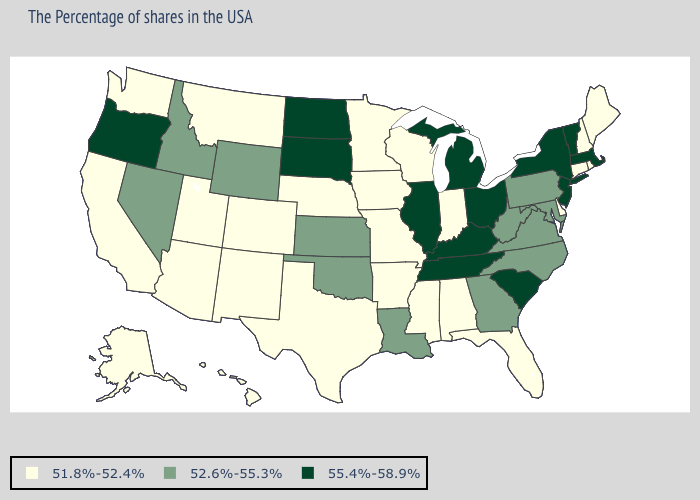How many symbols are there in the legend?
Concise answer only. 3. Does Florida have a lower value than Missouri?
Concise answer only. No. Which states hav the highest value in the West?
Give a very brief answer. Oregon. What is the value of Maryland?
Short answer required. 52.6%-55.3%. Does Ohio have the highest value in the USA?
Quick response, please. Yes. What is the lowest value in states that border Wisconsin?
Concise answer only. 51.8%-52.4%. Name the states that have a value in the range 52.6%-55.3%?
Be succinct. Maryland, Pennsylvania, Virginia, North Carolina, West Virginia, Georgia, Louisiana, Kansas, Oklahoma, Wyoming, Idaho, Nevada. Name the states that have a value in the range 52.6%-55.3%?
Quick response, please. Maryland, Pennsylvania, Virginia, North Carolina, West Virginia, Georgia, Louisiana, Kansas, Oklahoma, Wyoming, Idaho, Nevada. What is the lowest value in states that border Kansas?
Write a very short answer. 51.8%-52.4%. Which states have the lowest value in the Northeast?
Concise answer only. Maine, Rhode Island, New Hampshire, Connecticut. Does South Carolina have the lowest value in the South?
Be succinct. No. What is the highest value in the Northeast ?
Be succinct. 55.4%-58.9%. Which states have the highest value in the USA?
Short answer required. Massachusetts, Vermont, New York, New Jersey, South Carolina, Ohio, Michigan, Kentucky, Tennessee, Illinois, South Dakota, North Dakota, Oregon. Name the states that have a value in the range 51.8%-52.4%?
Answer briefly. Maine, Rhode Island, New Hampshire, Connecticut, Delaware, Florida, Indiana, Alabama, Wisconsin, Mississippi, Missouri, Arkansas, Minnesota, Iowa, Nebraska, Texas, Colorado, New Mexico, Utah, Montana, Arizona, California, Washington, Alaska, Hawaii. 